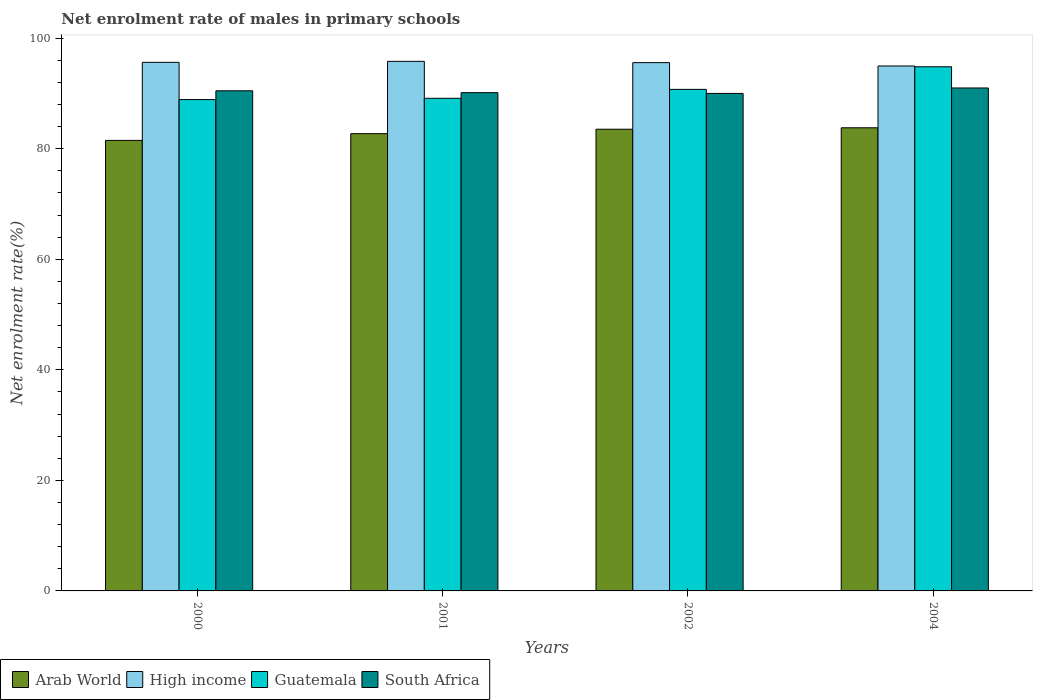Are the number of bars per tick equal to the number of legend labels?
Provide a succinct answer. Yes. What is the label of the 2nd group of bars from the left?
Make the answer very short. 2001. In how many cases, is the number of bars for a given year not equal to the number of legend labels?
Provide a succinct answer. 0. What is the net enrolment rate of males in primary schools in High income in 2002?
Provide a succinct answer. 95.58. Across all years, what is the maximum net enrolment rate of males in primary schools in South Africa?
Provide a succinct answer. 91. Across all years, what is the minimum net enrolment rate of males in primary schools in High income?
Give a very brief answer. 94.98. In which year was the net enrolment rate of males in primary schools in Guatemala maximum?
Make the answer very short. 2004. What is the total net enrolment rate of males in primary schools in High income in the graph?
Give a very brief answer. 382.01. What is the difference between the net enrolment rate of males in primary schools in High income in 2000 and that in 2004?
Ensure brevity in your answer.  0.66. What is the difference between the net enrolment rate of males in primary schools in High income in 2001 and the net enrolment rate of males in primary schools in Guatemala in 2002?
Your response must be concise. 5.07. What is the average net enrolment rate of males in primary schools in South Africa per year?
Ensure brevity in your answer.  90.41. In the year 2004, what is the difference between the net enrolment rate of males in primary schools in High income and net enrolment rate of males in primary schools in Guatemala?
Offer a very short reply. 0.14. What is the ratio of the net enrolment rate of males in primary schools in Guatemala in 2002 to that in 2004?
Provide a succinct answer. 0.96. Is the difference between the net enrolment rate of males in primary schools in High income in 2000 and 2002 greater than the difference between the net enrolment rate of males in primary schools in Guatemala in 2000 and 2002?
Offer a terse response. Yes. What is the difference between the highest and the second highest net enrolment rate of males in primary schools in Guatemala?
Make the answer very short. 4.09. What is the difference between the highest and the lowest net enrolment rate of males in primary schools in Guatemala?
Offer a very short reply. 5.94. Is the sum of the net enrolment rate of males in primary schools in Arab World in 2001 and 2004 greater than the maximum net enrolment rate of males in primary schools in South Africa across all years?
Provide a short and direct response. Yes. Is it the case that in every year, the sum of the net enrolment rate of males in primary schools in South Africa and net enrolment rate of males in primary schools in High income is greater than the net enrolment rate of males in primary schools in Arab World?
Provide a succinct answer. Yes. Does the graph contain any zero values?
Provide a short and direct response. No. Where does the legend appear in the graph?
Make the answer very short. Bottom left. How many legend labels are there?
Ensure brevity in your answer.  4. How are the legend labels stacked?
Offer a very short reply. Horizontal. What is the title of the graph?
Provide a short and direct response. Net enrolment rate of males in primary schools. Does "United Kingdom" appear as one of the legend labels in the graph?
Provide a succinct answer. No. What is the label or title of the X-axis?
Ensure brevity in your answer.  Years. What is the label or title of the Y-axis?
Offer a very short reply. Net enrolment rate(%). What is the Net enrolment rate(%) in Arab World in 2000?
Ensure brevity in your answer.  81.51. What is the Net enrolment rate(%) of High income in 2000?
Offer a terse response. 95.63. What is the Net enrolment rate(%) of Guatemala in 2000?
Offer a very short reply. 88.9. What is the Net enrolment rate(%) of South Africa in 2000?
Make the answer very short. 90.49. What is the Net enrolment rate(%) in Arab World in 2001?
Give a very brief answer. 82.73. What is the Net enrolment rate(%) in High income in 2001?
Make the answer very short. 95.81. What is the Net enrolment rate(%) of Guatemala in 2001?
Your answer should be compact. 89.13. What is the Net enrolment rate(%) of South Africa in 2001?
Make the answer very short. 90.15. What is the Net enrolment rate(%) in Arab World in 2002?
Give a very brief answer. 83.53. What is the Net enrolment rate(%) in High income in 2002?
Your answer should be very brief. 95.58. What is the Net enrolment rate(%) in Guatemala in 2002?
Give a very brief answer. 90.74. What is the Net enrolment rate(%) of South Africa in 2002?
Keep it short and to the point. 90.01. What is the Net enrolment rate(%) of Arab World in 2004?
Your response must be concise. 83.79. What is the Net enrolment rate(%) in High income in 2004?
Provide a succinct answer. 94.98. What is the Net enrolment rate(%) of Guatemala in 2004?
Offer a very short reply. 94.83. What is the Net enrolment rate(%) of South Africa in 2004?
Provide a succinct answer. 91. Across all years, what is the maximum Net enrolment rate(%) in Arab World?
Your answer should be compact. 83.79. Across all years, what is the maximum Net enrolment rate(%) of High income?
Your answer should be compact. 95.81. Across all years, what is the maximum Net enrolment rate(%) in Guatemala?
Your answer should be very brief. 94.83. Across all years, what is the maximum Net enrolment rate(%) of South Africa?
Give a very brief answer. 91. Across all years, what is the minimum Net enrolment rate(%) of Arab World?
Give a very brief answer. 81.51. Across all years, what is the minimum Net enrolment rate(%) in High income?
Provide a succinct answer. 94.98. Across all years, what is the minimum Net enrolment rate(%) of Guatemala?
Give a very brief answer. 88.9. Across all years, what is the minimum Net enrolment rate(%) of South Africa?
Provide a short and direct response. 90.01. What is the total Net enrolment rate(%) of Arab World in the graph?
Provide a succinct answer. 331.57. What is the total Net enrolment rate(%) of High income in the graph?
Offer a terse response. 382.01. What is the total Net enrolment rate(%) in Guatemala in the graph?
Ensure brevity in your answer.  363.6. What is the total Net enrolment rate(%) in South Africa in the graph?
Your answer should be very brief. 361.65. What is the difference between the Net enrolment rate(%) of Arab World in 2000 and that in 2001?
Provide a succinct answer. -1.22. What is the difference between the Net enrolment rate(%) of High income in 2000 and that in 2001?
Your answer should be compact. -0.18. What is the difference between the Net enrolment rate(%) in Guatemala in 2000 and that in 2001?
Your answer should be very brief. -0.23. What is the difference between the Net enrolment rate(%) of South Africa in 2000 and that in 2001?
Your answer should be compact. 0.34. What is the difference between the Net enrolment rate(%) in Arab World in 2000 and that in 2002?
Your answer should be compact. -2.02. What is the difference between the Net enrolment rate(%) in High income in 2000 and that in 2002?
Ensure brevity in your answer.  0.05. What is the difference between the Net enrolment rate(%) of Guatemala in 2000 and that in 2002?
Your answer should be compact. -1.85. What is the difference between the Net enrolment rate(%) in South Africa in 2000 and that in 2002?
Your answer should be compact. 0.48. What is the difference between the Net enrolment rate(%) of Arab World in 2000 and that in 2004?
Keep it short and to the point. -2.28. What is the difference between the Net enrolment rate(%) in High income in 2000 and that in 2004?
Provide a succinct answer. 0.66. What is the difference between the Net enrolment rate(%) in Guatemala in 2000 and that in 2004?
Your answer should be compact. -5.94. What is the difference between the Net enrolment rate(%) in South Africa in 2000 and that in 2004?
Your response must be concise. -0.51. What is the difference between the Net enrolment rate(%) of Arab World in 2001 and that in 2002?
Your response must be concise. -0.8. What is the difference between the Net enrolment rate(%) of High income in 2001 and that in 2002?
Give a very brief answer. 0.23. What is the difference between the Net enrolment rate(%) in Guatemala in 2001 and that in 2002?
Make the answer very short. -1.61. What is the difference between the Net enrolment rate(%) of South Africa in 2001 and that in 2002?
Offer a very short reply. 0.14. What is the difference between the Net enrolment rate(%) in Arab World in 2001 and that in 2004?
Provide a short and direct response. -1.06. What is the difference between the Net enrolment rate(%) of High income in 2001 and that in 2004?
Your answer should be compact. 0.84. What is the difference between the Net enrolment rate(%) in Guatemala in 2001 and that in 2004?
Offer a very short reply. -5.71. What is the difference between the Net enrolment rate(%) in South Africa in 2001 and that in 2004?
Keep it short and to the point. -0.85. What is the difference between the Net enrolment rate(%) in Arab World in 2002 and that in 2004?
Give a very brief answer. -0.26. What is the difference between the Net enrolment rate(%) in High income in 2002 and that in 2004?
Ensure brevity in your answer.  0.6. What is the difference between the Net enrolment rate(%) of Guatemala in 2002 and that in 2004?
Give a very brief answer. -4.09. What is the difference between the Net enrolment rate(%) in South Africa in 2002 and that in 2004?
Provide a short and direct response. -0.99. What is the difference between the Net enrolment rate(%) of Arab World in 2000 and the Net enrolment rate(%) of High income in 2001?
Make the answer very short. -14.3. What is the difference between the Net enrolment rate(%) in Arab World in 2000 and the Net enrolment rate(%) in Guatemala in 2001?
Provide a short and direct response. -7.62. What is the difference between the Net enrolment rate(%) in Arab World in 2000 and the Net enrolment rate(%) in South Africa in 2001?
Provide a short and direct response. -8.64. What is the difference between the Net enrolment rate(%) in High income in 2000 and the Net enrolment rate(%) in Guatemala in 2001?
Your answer should be compact. 6.51. What is the difference between the Net enrolment rate(%) of High income in 2000 and the Net enrolment rate(%) of South Africa in 2001?
Offer a terse response. 5.49. What is the difference between the Net enrolment rate(%) in Guatemala in 2000 and the Net enrolment rate(%) in South Africa in 2001?
Give a very brief answer. -1.25. What is the difference between the Net enrolment rate(%) in Arab World in 2000 and the Net enrolment rate(%) in High income in 2002?
Offer a very short reply. -14.07. What is the difference between the Net enrolment rate(%) of Arab World in 2000 and the Net enrolment rate(%) of Guatemala in 2002?
Offer a terse response. -9.23. What is the difference between the Net enrolment rate(%) of Arab World in 2000 and the Net enrolment rate(%) of South Africa in 2002?
Keep it short and to the point. -8.5. What is the difference between the Net enrolment rate(%) of High income in 2000 and the Net enrolment rate(%) of Guatemala in 2002?
Your response must be concise. 4.89. What is the difference between the Net enrolment rate(%) in High income in 2000 and the Net enrolment rate(%) in South Africa in 2002?
Offer a terse response. 5.62. What is the difference between the Net enrolment rate(%) of Guatemala in 2000 and the Net enrolment rate(%) of South Africa in 2002?
Ensure brevity in your answer.  -1.11. What is the difference between the Net enrolment rate(%) of Arab World in 2000 and the Net enrolment rate(%) of High income in 2004?
Provide a short and direct response. -13.47. What is the difference between the Net enrolment rate(%) in Arab World in 2000 and the Net enrolment rate(%) in Guatemala in 2004?
Offer a very short reply. -13.32. What is the difference between the Net enrolment rate(%) in Arab World in 2000 and the Net enrolment rate(%) in South Africa in 2004?
Your response must be concise. -9.49. What is the difference between the Net enrolment rate(%) in High income in 2000 and the Net enrolment rate(%) in Guatemala in 2004?
Offer a terse response. 0.8. What is the difference between the Net enrolment rate(%) of High income in 2000 and the Net enrolment rate(%) of South Africa in 2004?
Make the answer very short. 4.64. What is the difference between the Net enrolment rate(%) of Guatemala in 2000 and the Net enrolment rate(%) of South Africa in 2004?
Provide a succinct answer. -2.1. What is the difference between the Net enrolment rate(%) of Arab World in 2001 and the Net enrolment rate(%) of High income in 2002?
Your answer should be compact. -12.85. What is the difference between the Net enrolment rate(%) in Arab World in 2001 and the Net enrolment rate(%) in Guatemala in 2002?
Your answer should be very brief. -8.01. What is the difference between the Net enrolment rate(%) in Arab World in 2001 and the Net enrolment rate(%) in South Africa in 2002?
Your answer should be compact. -7.28. What is the difference between the Net enrolment rate(%) in High income in 2001 and the Net enrolment rate(%) in Guatemala in 2002?
Offer a very short reply. 5.07. What is the difference between the Net enrolment rate(%) of High income in 2001 and the Net enrolment rate(%) of South Africa in 2002?
Make the answer very short. 5.8. What is the difference between the Net enrolment rate(%) of Guatemala in 2001 and the Net enrolment rate(%) of South Africa in 2002?
Your answer should be compact. -0.88. What is the difference between the Net enrolment rate(%) in Arab World in 2001 and the Net enrolment rate(%) in High income in 2004?
Provide a succinct answer. -12.25. What is the difference between the Net enrolment rate(%) of Arab World in 2001 and the Net enrolment rate(%) of Guatemala in 2004?
Your answer should be very brief. -12.1. What is the difference between the Net enrolment rate(%) of Arab World in 2001 and the Net enrolment rate(%) of South Africa in 2004?
Provide a succinct answer. -8.26. What is the difference between the Net enrolment rate(%) in High income in 2001 and the Net enrolment rate(%) in Guatemala in 2004?
Your response must be concise. 0.98. What is the difference between the Net enrolment rate(%) of High income in 2001 and the Net enrolment rate(%) of South Africa in 2004?
Your answer should be very brief. 4.82. What is the difference between the Net enrolment rate(%) in Guatemala in 2001 and the Net enrolment rate(%) in South Africa in 2004?
Provide a short and direct response. -1.87. What is the difference between the Net enrolment rate(%) in Arab World in 2002 and the Net enrolment rate(%) in High income in 2004?
Make the answer very short. -11.44. What is the difference between the Net enrolment rate(%) in Arab World in 2002 and the Net enrolment rate(%) in Guatemala in 2004?
Offer a terse response. -11.3. What is the difference between the Net enrolment rate(%) of Arab World in 2002 and the Net enrolment rate(%) of South Africa in 2004?
Provide a short and direct response. -7.46. What is the difference between the Net enrolment rate(%) of High income in 2002 and the Net enrolment rate(%) of Guatemala in 2004?
Offer a very short reply. 0.75. What is the difference between the Net enrolment rate(%) in High income in 2002 and the Net enrolment rate(%) in South Africa in 2004?
Your answer should be compact. 4.59. What is the difference between the Net enrolment rate(%) of Guatemala in 2002 and the Net enrolment rate(%) of South Africa in 2004?
Your answer should be compact. -0.26. What is the average Net enrolment rate(%) in Arab World per year?
Keep it short and to the point. 82.89. What is the average Net enrolment rate(%) of High income per year?
Keep it short and to the point. 95.5. What is the average Net enrolment rate(%) in Guatemala per year?
Your answer should be compact. 90.9. What is the average Net enrolment rate(%) in South Africa per year?
Give a very brief answer. 90.41. In the year 2000, what is the difference between the Net enrolment rate(%) of Arab World and Net enrolment rate(%) of High income?
Offer a terse response. -14.12. In the year 2000, what is the difference between the Net enrolment rate(%) in Arab World and Net enrolment rate(%) in Guatemala?
Ensure brevity in your answer.  -7.38. In the year 2000, what is the difference between the Net enrolment rate(%) of Arab World and Net enrolment rate(%) of South Africa?
Your answer should be very brief. -8.98. In the year 2000, what is the difference between the Net enrolment rate(%) in High income and Net enrolment rate(%) in Guatemala?
Provide a succinct answer. 6.74. In the year 2000, what is the difference between the Net enrolment rate(%) in High income and Net enrolment rate(%) in South Africa?
Provide a succinct answer. 5.15. In the year 2000, what is the difference between the Net enrolment rate(%) of Guatemala and Net enrolment rate(%) of South Africa?
Make the answer very short. -1.59. In the year 2001, what is the difference between the Net enrolment rate(%) in Arab World and Net enrolment rate(%) in High income?
Give a very brief answer. -13.08. In the year 2001, what is the difference between the Net enrolment rate(%) in Arab World and Net enrolment rate(%) in Guatemala?
Your response must be concise. -6.4. In the year 2001, what is the difference between the Net enrolment rate(%) of Arab World and Net enrolment rate(%) of South Africa?
Your answer should be compact. -7.42. In the year 2001, what is the difference between the Net enrolment rate(%) in High income and Net enrolment rate(%) in Guatemala?
Give a very brief answer. 6.69. In the year 2001, what is the difference between the Net enrolment rate(%) in High income and Net enrolment rate(%) in South Africa?
Your answer should be compact. 5.66. In the year 2001, what is the difference between the Net enrolment rate(%) in Guatemala and Net enrolment rate(%) in South Africa?
Keep it short and to the point. -1.02. In the year 2002, what is the difference between the Net enrolment rate(%) in Arab World and Net enrolment rate(%) in High income?
Your answer should be very brief. -12.05. In the year 2002, what is the difference between the Net enrolment rate(%) in Arab World and Net enrolment rate(%) in Guatemala?
Keep it short and to the point. -7.21. In the year 2002, what is the difference between the Net enrolment rate(%) in Arab World and Net enrolment rate(%) in South Africa?
Provide a succinct answer. -6.48. In the year 2002, what is the difference between the Net enrolment rate(%) of High income and Net enrolment rate(%) of Guatemala?
Ensure brevity in your answer.  4.84. In the year 2002, what is the difference between the Net enrolment rate(%) in High income and Net enrolment rate(%) in South Africa?
Your response must be concise. 5.57. In the year 2002, what is the difference between the Net enrolment rate(%) in Guatemala and Net enrolment rate(%) in South Africa?
Make the answer very short. 0.73. In the year 2004, what is the difference between the Net enrolment rate(%) of Arab World and Net enrolment rate(%) of High income?
Provide a succinct answer. -11.19. In the year 2004, what is the difference between the Net enrolment rate(%) of Arab World and Net enrolment rate(%) of Guatemala?
Offer a terse response. -11.04. In the year 2004, what is the difference between the Net enrolment rate(%) of Arab World and Net enrolment rate(%) of South Africa?
Your answer should be very brief. -7.2. In the year 2004, what is the difference between the Net enrolment rate(%) of High income and Net enrolment rate(%) of Guatemala?
Your answer should be compact. 0.14. In the year 2004, what is the difference between the Net enrolment rate(%) of High income and Net enrolment rate(%) of South Africa?
Give a very brief answer. 3.98. In the year 2004, what is the difference between the Net enrolment rate(%) in Guatemala and Net enrolment rate(%) in South Africa?
Offer a terse response. 3.84. What is the ratio of the Net enrolment rate(%) of Arab World in 2000 to that in 2001?
Provide a succinct answer. 0.99. What is the ratio of the Net enrolment rate(%) of High income in 2000 to that in 2001?
Your answer should be very brief. 1. What is the ratio of the Net enrolment rate(%) in South Africa in 2000 to that in 2001?
Ensure brevity in your answer.  1. What is the ratio of the Net enrolment rate(%) of Arab World in 2000 to that in 2002?
Make the answer very short. 0.98. What is the ratio of the Net enrolment rate(%) in High income in 2000 to that in 2002?
Keep it short and to the point. 1. What is the ratio of the Net enrolment rate(%) of Guatemala in 2000 to that in 2002?
Keep it short and to the point. 0.98. What is the ratio of the Net enrolment rate(%) of Arab World in 2000 to that in 2004?
Make the answer very short. 0.97. What is the ratio of the Net enrolment rate(%) in High income in 2000 to that in 2004?
Your response must be concise. 1.01. What is the ratio of the Net enrolment rate(%) of Guatemala in 2000 to that in 2004?
Make the answer very short. 0.94. What is the ratio of the Net enrolment rate(%) in Arab World in 2001 to that in 2002?
Provide a succinct answer. 0.99. What is the ratio of the Net enrolment rate(%) in Guatemala in 2001 to that in 2002?
Ensure brevity in your answer.  0.98. What is the ratio of the Net enrolment rate(%) of South Africa in 2001 to that in 2002?
Your answer should be very brief. 1. What is the ratio of the Net enrolment rate(%) of Arab World in 2001 to that in 2004?
Make the answer very short. 0.99. What is the ratio of the Net enrolment rate(%) of High income in 2001 to that in 2004?
Make the answer very short. 1.01. What is the ratio of the Net enrolment rate(%) of Guatemala in 2001 to that in 2004?
Ensure brevity in your answer.  0.94. What is the ratio of the Net enrolment rate(%) of South Africa in 2001 to that in 2004?
Provide a succinct answer. 0.99. What is the ratio of the Net enrolment rate(%) of High income in 2002 to that in 2004?
Ensure brevity in your answer.  1.01. What is the ratio of the Net enrolment rate(%) of Guatemala in 2002 to that in 2004?
Offer a very short reply. 0.96. What is the difference between the highest and the second highest Net enrolment rate(%) of Arab World?
Keep it short and to the point. 0.26. What is the difference between the highest and the second highest Net enrolment rate(%) of High income?
Your answer should be compact. 0.18. What is the difference between the highest and the second highest Net enrolment rate(%) of Guatemala?
Your answer should be very brief. 4.09. What is the difference between the highest and the second highest Net enrolment rate(%) in South Africa?
Offer a very short reply. 0.51. What is the difference between the highest and the lowest Net enrolment rate(%) of Arab World?
Keep it short and to the point. 2.28. What is the difference between the highest and the lowest Net enrolment rate(%) of High income?
Ensure brevity in your answer.  0.84. What is the difference between the highest and the lowest Net enrolment rate(%) in Guatemala?
Your answer should be very brief. 5.94. 